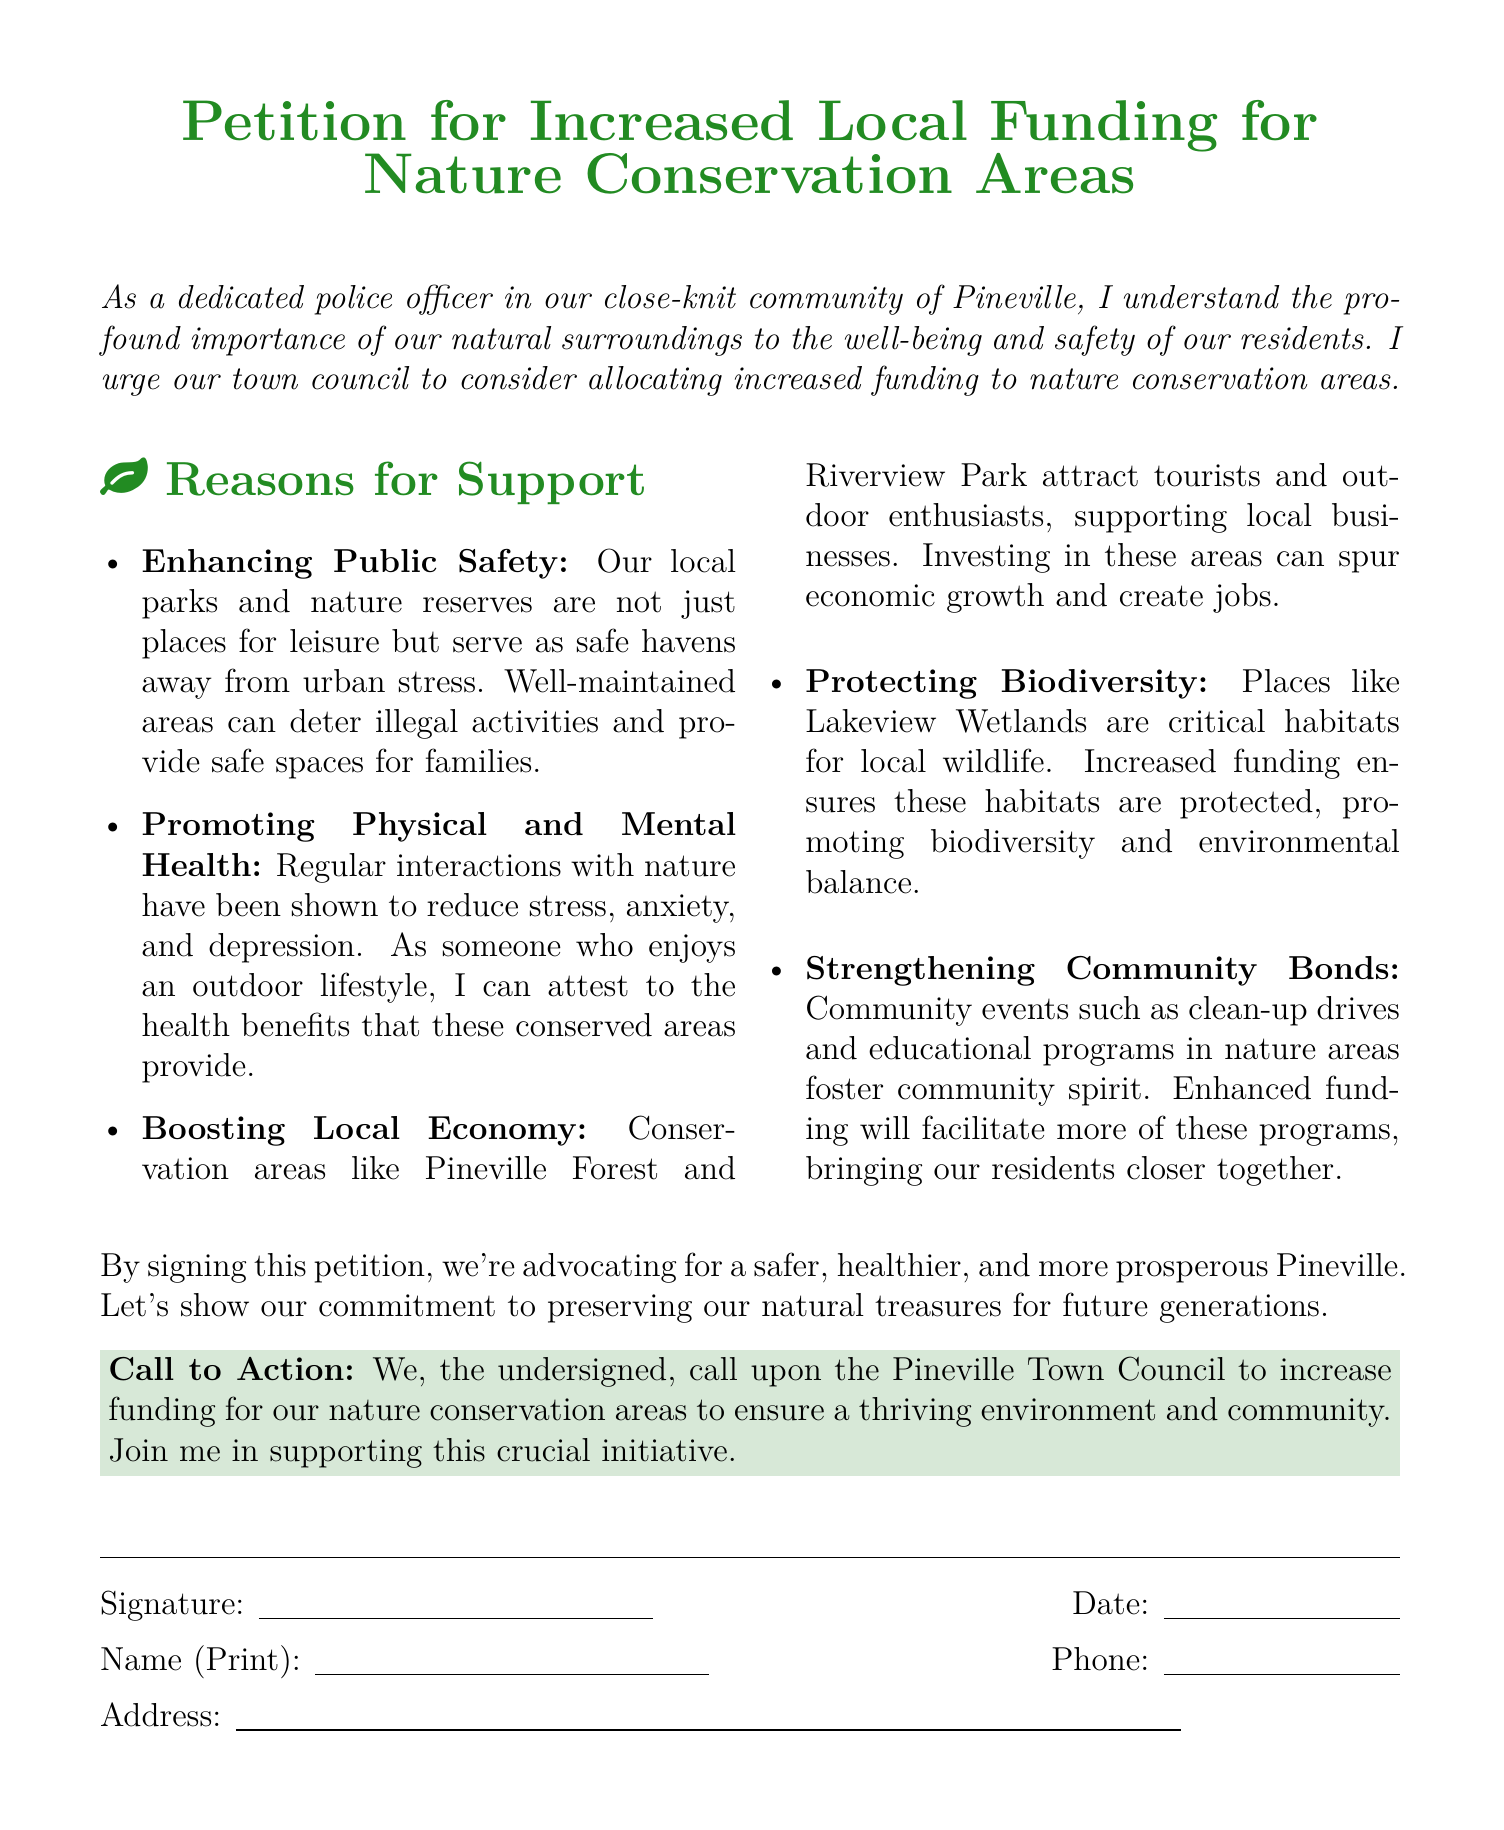What is the title of the document? The title is prominently displayed at the top of the document in a larger font size and bold formatting.
Answer: Petition for Increased Local Funding for Nature Conservation Areas Who is the author of the petition? The petition begins with a statement that identifies the author as a police officer in Pineville.
Answer: A dedicated police officer in our close-knit community of Pineville What is one reason mentioned for supporting increased funding? The document lists several reasons, and this one is specifically highlighted to inform readers of the benefits of local funding.
Answer: Enhancing Public Safety What specific location is mentioned as a conservation area? The petition references specific local nature conservation areas that require funding.
Answer: Lakeview Wetlands What does the call to action urge the town council to do? The call to action is a direct appeal to local government to make a decision about resource allocation.
Answer: Increase funding for our nature conservation areas What are community events intended to foster? The document explicitly mentions how certain activities are meant to achieve a particular goal regarding community interaction.
Answer: Community spirit When is the signature date to be filled in? The format provides space for a specific input, indicating the date when the petition is signed.
Answer: Date: What color is used for the title of the petition? The title features a specific color that contributes to the overall theme of the petition document.
Answer: Forest green Which section of the document contains the reasoning for support? The document categorizes its content, and this section is specifically designated for outlining support reasons.
Answer: Reasons for Support How are the community events described in relation to funding? The document connects community events to the impact increased funding could have on these initiatives.
Answer: Facilitate more of these programs 